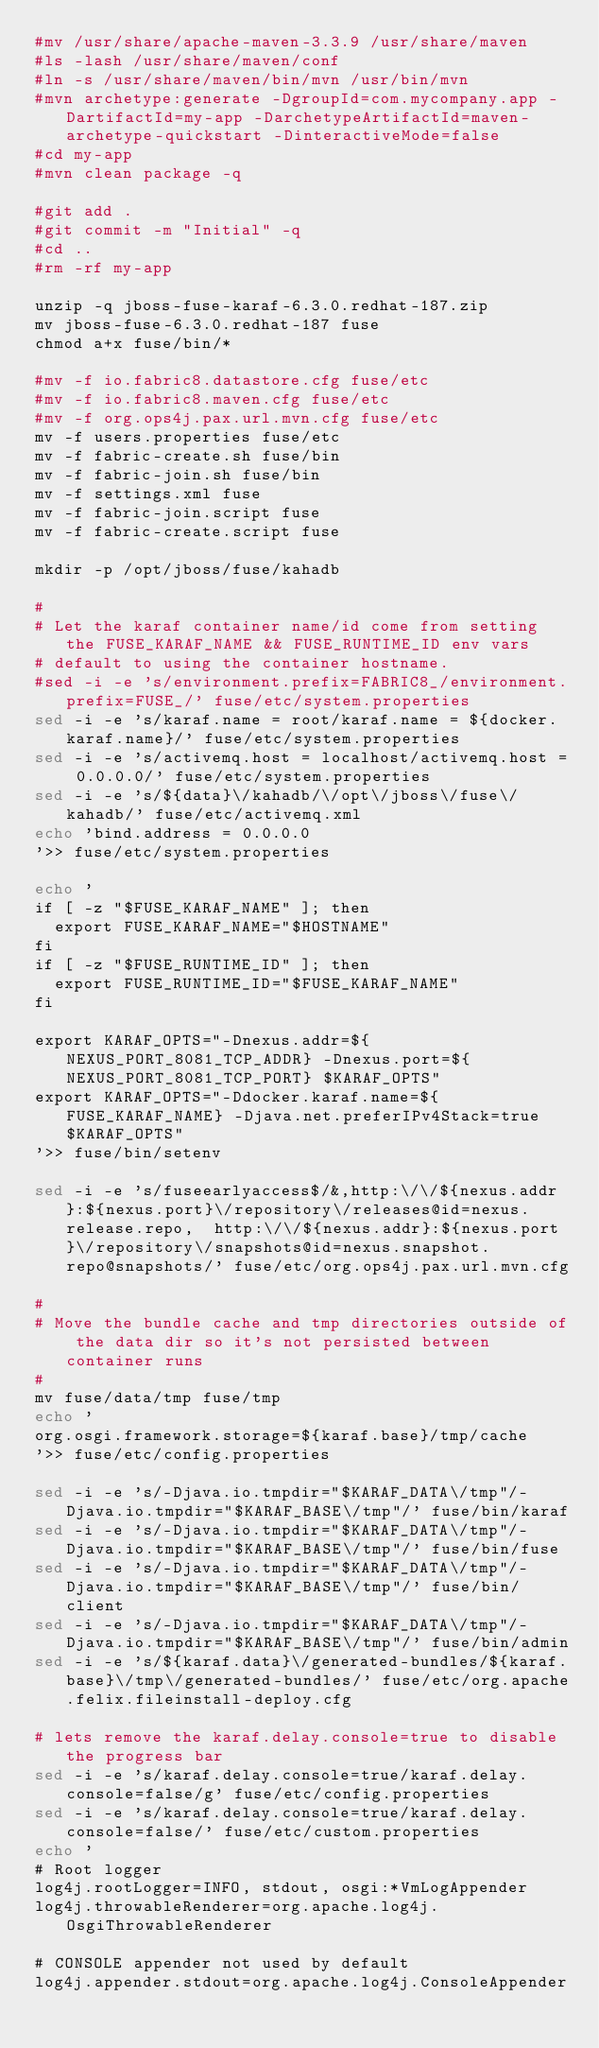Convert code to text. <code><loc_0><loc_0><loc_500><loc_500><_Bash_>#mv /usr/share/apache-maven-3.3.9 /usr/share/maven
#ls -lash /usr/share/maven/conf
#ln -s /usr/share/maven/bin/mvn /usr/bin/mvn
#mvn archetype:generate -DgroupId=com.mycompany.app -DartifactId=my-app -DarchetypeArtifactId=maven-archetype-quickstart -DinteractiveMode=false
#cd my-app
#mvn clean package -q

#git add .
#git commit -m "Initial" -q
#cd ..
#rm -rf my-app

unzip -q jboss-fuse-karaf-6.3.0.redhat-187.zip
mv jboss-fuse-6.3.0.redhat-187 fuse
chmod a+x fuse/bin/*

#mv -f io.fabric8.datastore.cfg fuse/etc
#mv -f io.fabric8.maven.cfg fuse/etc
#mv -f org.ops4j.pax.url.mvn.cfg fuse/etc
mv -f users.properties fuse/etc
mv -f fabric-create.sh fuse/bin
mv -f fabric-join.sh fuse/bin
mv -f settings.xml fuse
mv -f fabric-join.script fuse
mv -f fabric-create.script fuse

mkdir -p /opt/jboss/fuse/kahadb

#
# Let the karaf container name/id come from setting the FUSE_KARAF_NAME && FUSE_RUNTIME_ID env vars
# default to using the container hostname.
#sed -i -e 's/environment.prefix=FABRIC8_/environment.prefix=FUSE_/' fuse/etc/system.properties
sed -i -e 's/karaf.name = root/karaf.name = ${docker.karaf.name}/' fuse/etc/system.properties
sed -i -e 's/activemq.host = localhost/activemq.host = 0.0.0.0/' fuse/etc/system.properties
sed -i -e 's/${data}\/kahadb/\/opt\/jboss\/fuse\/kahadb/' fuse/etc/activemq.xml
echo 'bind.address = 0.0.0.0
'>> fuse/etc/system.properties

echo '
if [ -z "$FUSE_KARAF_NAME" ]; then 
  export FUSE_KARAF_NAME="$HOSTNAME"
fi
if [ -z "$FUSE_RUNTIME_ID" ]; then 
  export FUSE_RUNTIME_ID="$FUSE_KARAF_NAME"
fi

export KARAF_OPTS="-Dnexus.addr=${NEXUS_PORT_8081_TCP_ADDR} -Dnexus.port=${NEXUS_PORT_8081_TCP_PORT} $KARAF_OPTS"
export KARAF_OPTS="-Ddocker.karaf.name=${FUSE_KARAF_NAME} -Djava.net.preferIPv4Stack=true $KARAF_OPTS"
'>> fuse/bin/setenv

sed -i -e 's/fuseearlyaccess$/&,http:\/\/${nexus.addr}:${nexus.port}\/repository\/releases@id=nexus.release.repo,  http:\/\/${nexus.addr}:${nexus.port}\/repository\/snapshots@id=nexus.snapshot.repo@snapshots/' fuse/etc/org.ops4j.pax.url.mvn.cfg

#
# Move the bundle cache and tmp directories outside of the data dir so it's not persisted between container runs
#
mv fuse/data/tmp fuse/tmp
echo '
org.osgi.framework.storage=${karaf.base}/tmp/cache
'>> fuse/etc/config.properties

sed -i -e 's/-Djava.io.tmpdir="$KARAF_DATA\/tmp"/-Djava.io.tmpdir="$KARAF_BASE\/tmp"/' fuse/bin/karaf
sed -i -e 's/-Djava.io.tmpdir="$KARAF_DATA\/tmp"/-Djava.io.tmpdir="$KARAF_BASE\/tmp"/' fuse/bin/fuse
sed -i -e 's/-Djava.io.tmpdir="$KARAF_DATA\/tmp"/-Djava.io.tmpdir="$KARAF_BASE\/tmp"/' fuse/bin/client
sed -i -e 's/-Djava.io.tmpdir="$KARAF_DATA\/tmp"/-Djava.io.tmpdir="$KARAF_BASE\/tmp"/' fuse/bin/admin
sed -i -e 's/${karaf.data}\/generated-bundles/${karaf.base}\/tmp\/generated-bundles/' fuse/etc/org.apache.felix.fileinstall-deploy.cfg

# lets remove the karaf.delay.console=true to disable the progress bar
sed -i -e 's/karaf.delay.console=true/karaf.delay.console=false/g' fuse/etc/config.properties
sed -i -e 's/karaf.delay.console=true/karaf.delay.console=false/' fuse/etc/custom.properties
echo '
# Root logger
log4j.rootLogger=INFO, stdout, osgi:*VmLogAppender
log4j.throwableRenderer=org.apache.log4j.OsgiThrowableRenderer

# CONSOLE appender not used by default
log4j.appender.stdout=org.apache.log4j.ConsoleAppender</code> 